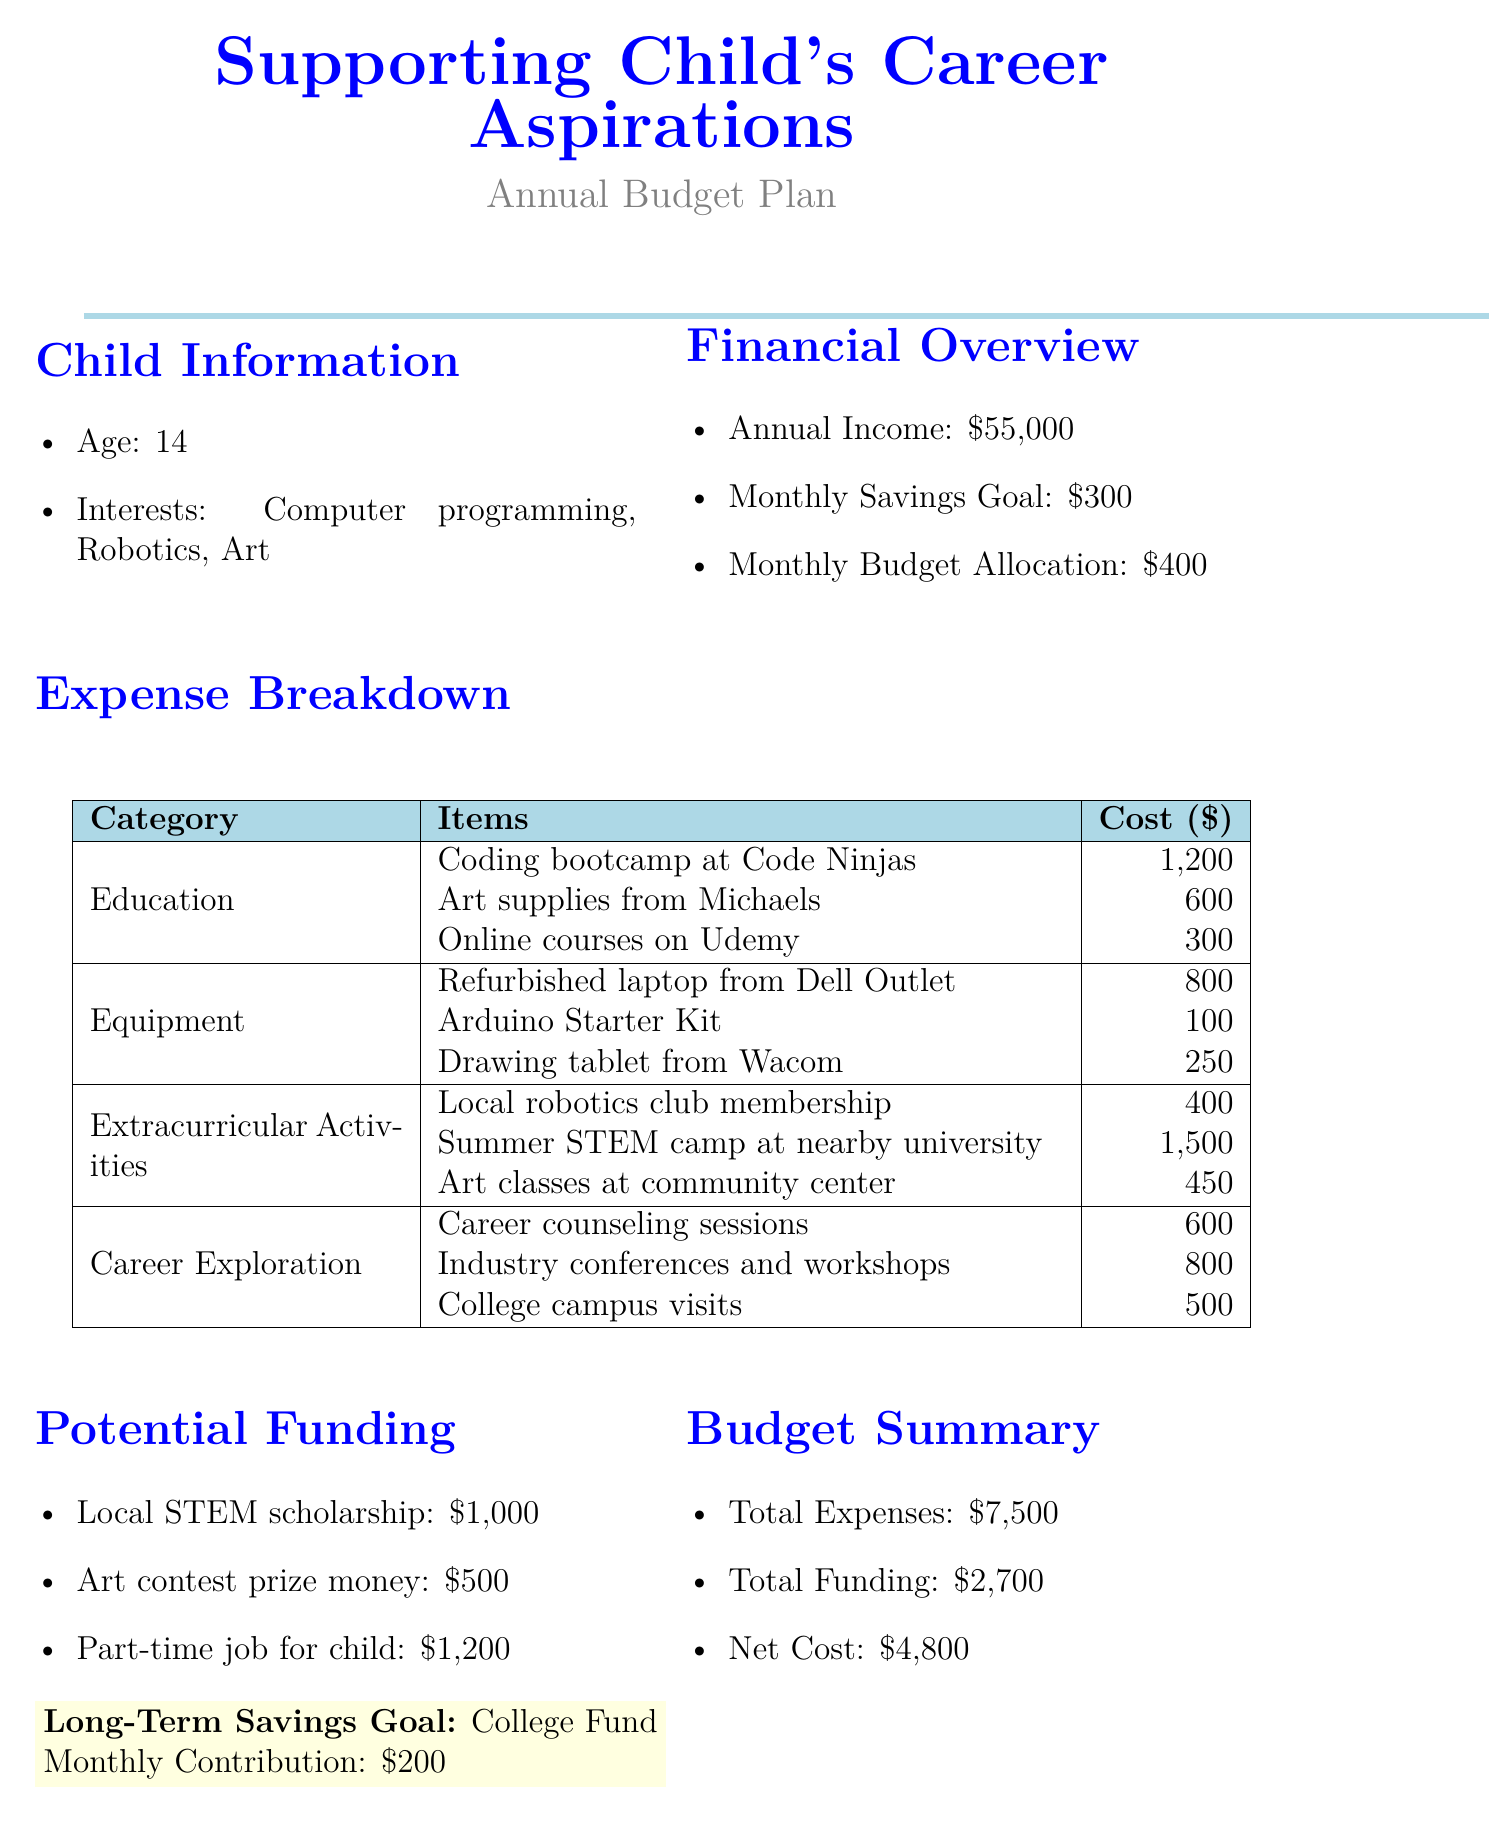what is the total annual income? The annual income is specified as $55,000 in the document.
Answer: $55,000 how much is allocated monthly for the budget? The document states that the monthly budget allocation is $400.
Answer: $400 what is the cost of the coding bootcamp? The coding bootcamp at Code Ninjas is listed with a cost of $1,200.
Answer: $1,200 what is the net cost after funding? The net cost is calculated by subtracting total funding from total expenses, resulting in $4,800.
Answer: $4,800 how much does the summer STEM camp cost? The cost for the summer STEM camp at the nearby university is $1,500.
Answer: $1,500 how much is the potential funding from the local STEM scholarship? The local STEM scholarship offers a potential funding amount of $1,000.
Answer: $1,000 what is the total amount of expenses listed? The total expenses are listed as $7,500 in the budget summary.
Answer: $7,500 what is the purpose of the long-term savings goal? The purpose of the long-term savings goal is to fund college expenses.
Answer: College fund how many interests does the child have? The child has three interests listed in the document: computer programming, robotics, and art.
Answer: three 